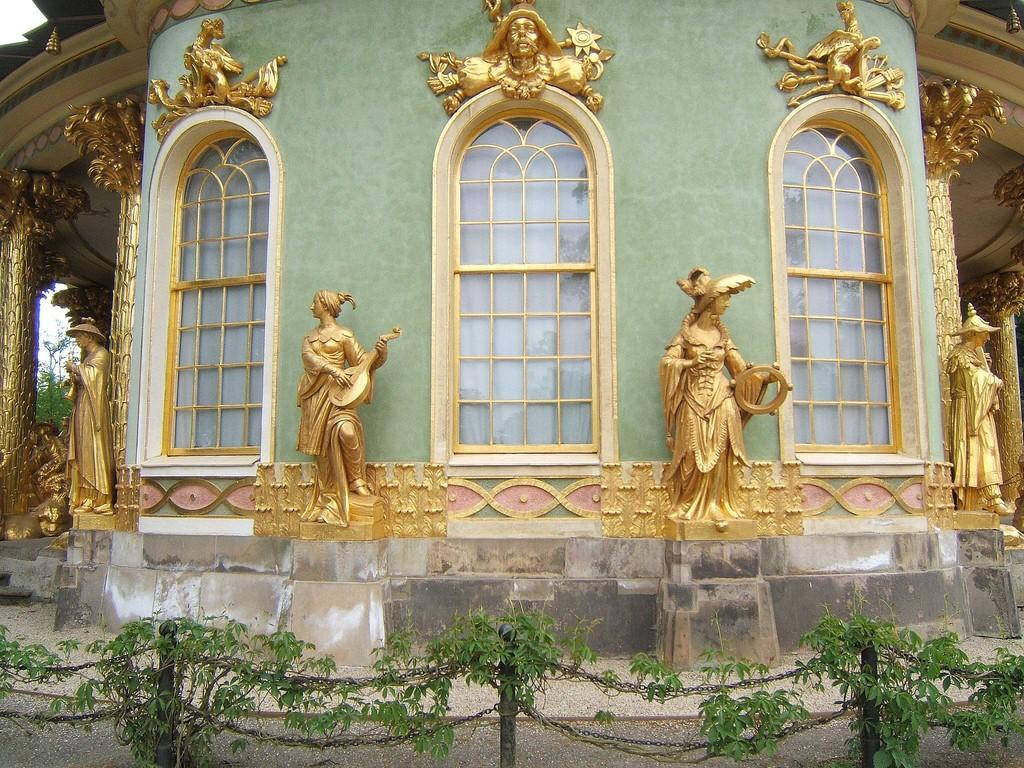What type of structure is visible in the image? There is a building in the image. What architectural features can be seen on the building? The building has windows and pillars. Are there any other objects or figures in the image besides the building? Yes, there are statues, poles, and plants in the image. What type of rabbits can be seen playing volleyball in the image? There are no rabbits or volleyball in the image; it features a building with windows and pillars, as well as statues, poles, and plants. 